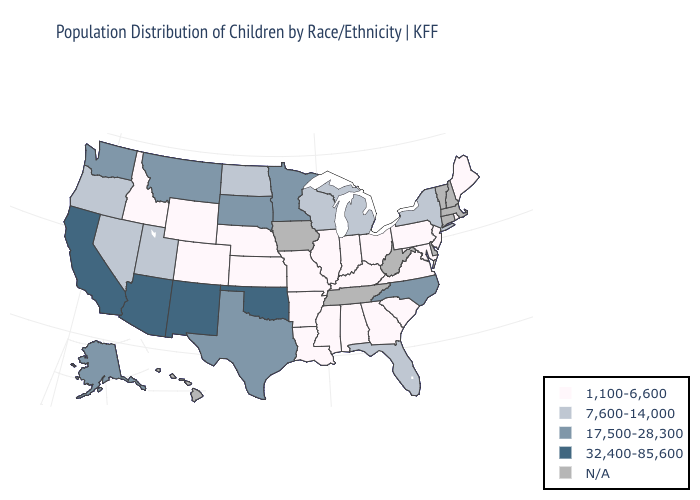What is the value of Vermont?
Be succinct. N/A. Does the map have missing data?
Keep it brief. Yes. What is the highest value in states that border Michigan?
Write a very short answer. 7,600-14,000. What is the value of Florida?
Concise answer only. 7,600-14,000. Does the first symbol in the legend represent the smallest category?
Give a very brief answer. Yes. Is the legend a continuous bar?
Concise answer only. No. What is the value of Ohio?
Give a very brief answer. 1,100-6,600. Name the states that have a value in the range 17,500-28,300?
Concise answer only. Alaska, Minnesota, Montana, North Carolina, South Dakota, Texas, Washington. What is the value of Georgia?
Be succinct. 1,100-6,600. Name the states that have a value in the range N/A?
Keep it brief. Connecticut, Delaware, Hawaii, Iowa, Massachusetts, New Hampshire, Tennessee, Vermont, West Virginia. What is the value of Washington?
Write a very short answer. 17,500-28,300. How many symbols are there in the legend?
Answer briefly. 5. Name the states that have a value in the range 1,100-6,600?
Short answer required. Alabama, Arkansas, Colorado, Georgia, Idaho, Illinois, Indiana, Kansas, Kentucky, Louisiana, Maine, Maryland, Mississippi, Missouri, Nebraska, New Jersey, Ohio, Pennsylvania, Rhode Island, South Carolina, Virginia, Wyoming. Does the first symbol in the legend represent the smallest category?
Short answer required. Yes. 